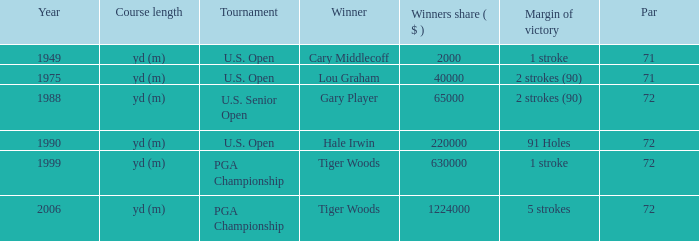When cary middlecoff is the winner how many pars are there? 1.0. 